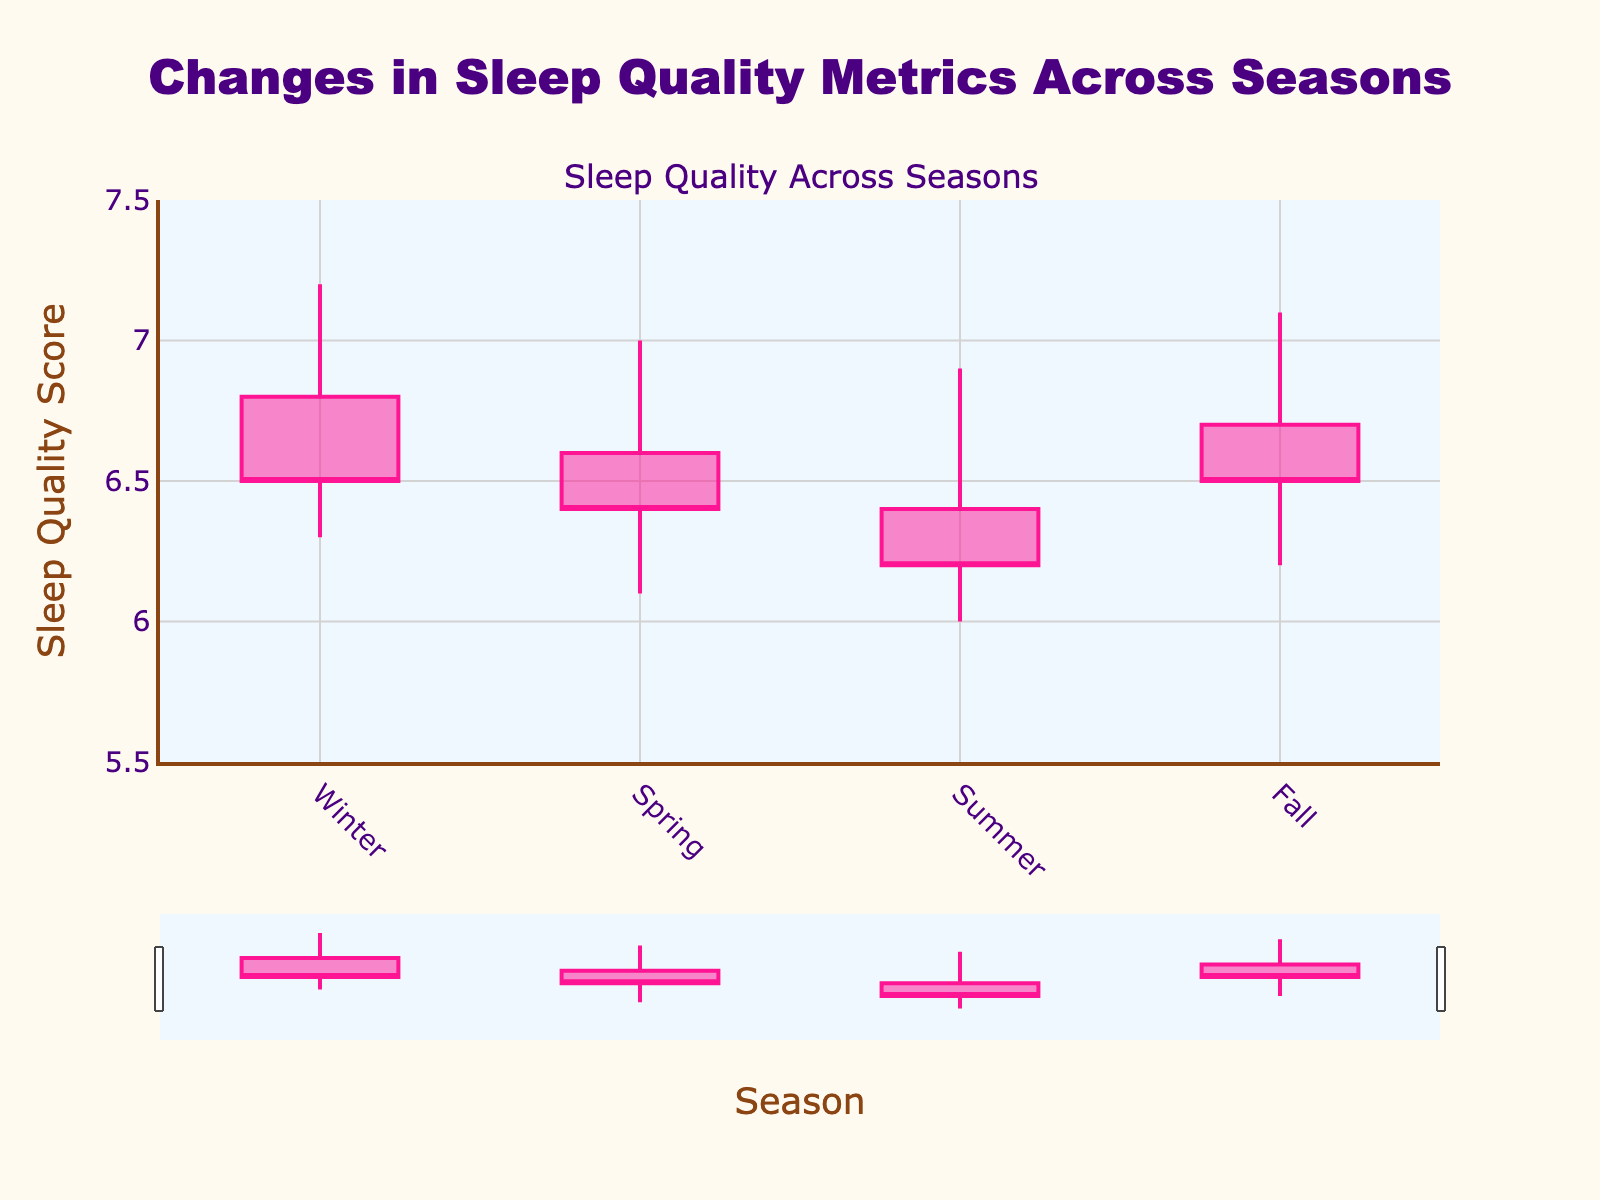What's the title of the figure? The title is written in large, colored text at the top of the figure.
Answer: Changes in Sleep Quality Metrics Across Seasons What seasons are represented in the figure? The x-axis lists all the seasons in the order of appearance.
Answer: Winter, Spring, Summer, Fall Which season has the highest sleep quality score at its peak? The highest point in the candlestick for each season represents the peak sleep quality score. The tallest candlestick is for Winter.
Answer: Winter Which season shows the lowest sleep quality score? The lowest point in each candlestick indicates the minimum sleep quality score for each season. The lowest point is in Summer.
Answer: Summer What is the difference between the highest and lowest sleep quality scores in Spring? Subtract the lowest value in the Spring candlestick from the highest value in the same candlestick. The values are 7.0 (High) and 6.1 (Low). 7.0 - 6.1 = 0.9.
Answer: 0.9 Which seasons have the same closing sleep quality score? Compare the close values for each season to find matches. Both Winter and Fall have a close value of 6.5.
Answer: Winter and Fall What is the average opening sleep quality score across all seasons? Sum all opening values and divide by the number of seasons. (6.8 + 6.6 + 6.4 + 6.7) / 4 = 26.5 / 4 = 6.625
Answer: 6.625 What color represents a decrease in sleep quality and in which season(s) does it appear? The decreasing line color is described by the plot configuration and visible in the figure as a specific color. Only Summer has a candlestick of that color.
Answer: Deep Pink, Summer How much does the sleep quality score range differ between Winter and Fall? Compute the range for both Winter (7.2-6.3=0.9) and Fall (7.1-6.2=0.9). Then subtract these ranges: 0.9 - 0.9 = 0.
Answer: 0 Which season's sleep quality opened higher: Spring or Summer? Compare the open values of Spring and Summer from the figure. Spring's open is 6.6, Summer's open is 6.4.
Answer: Spring 